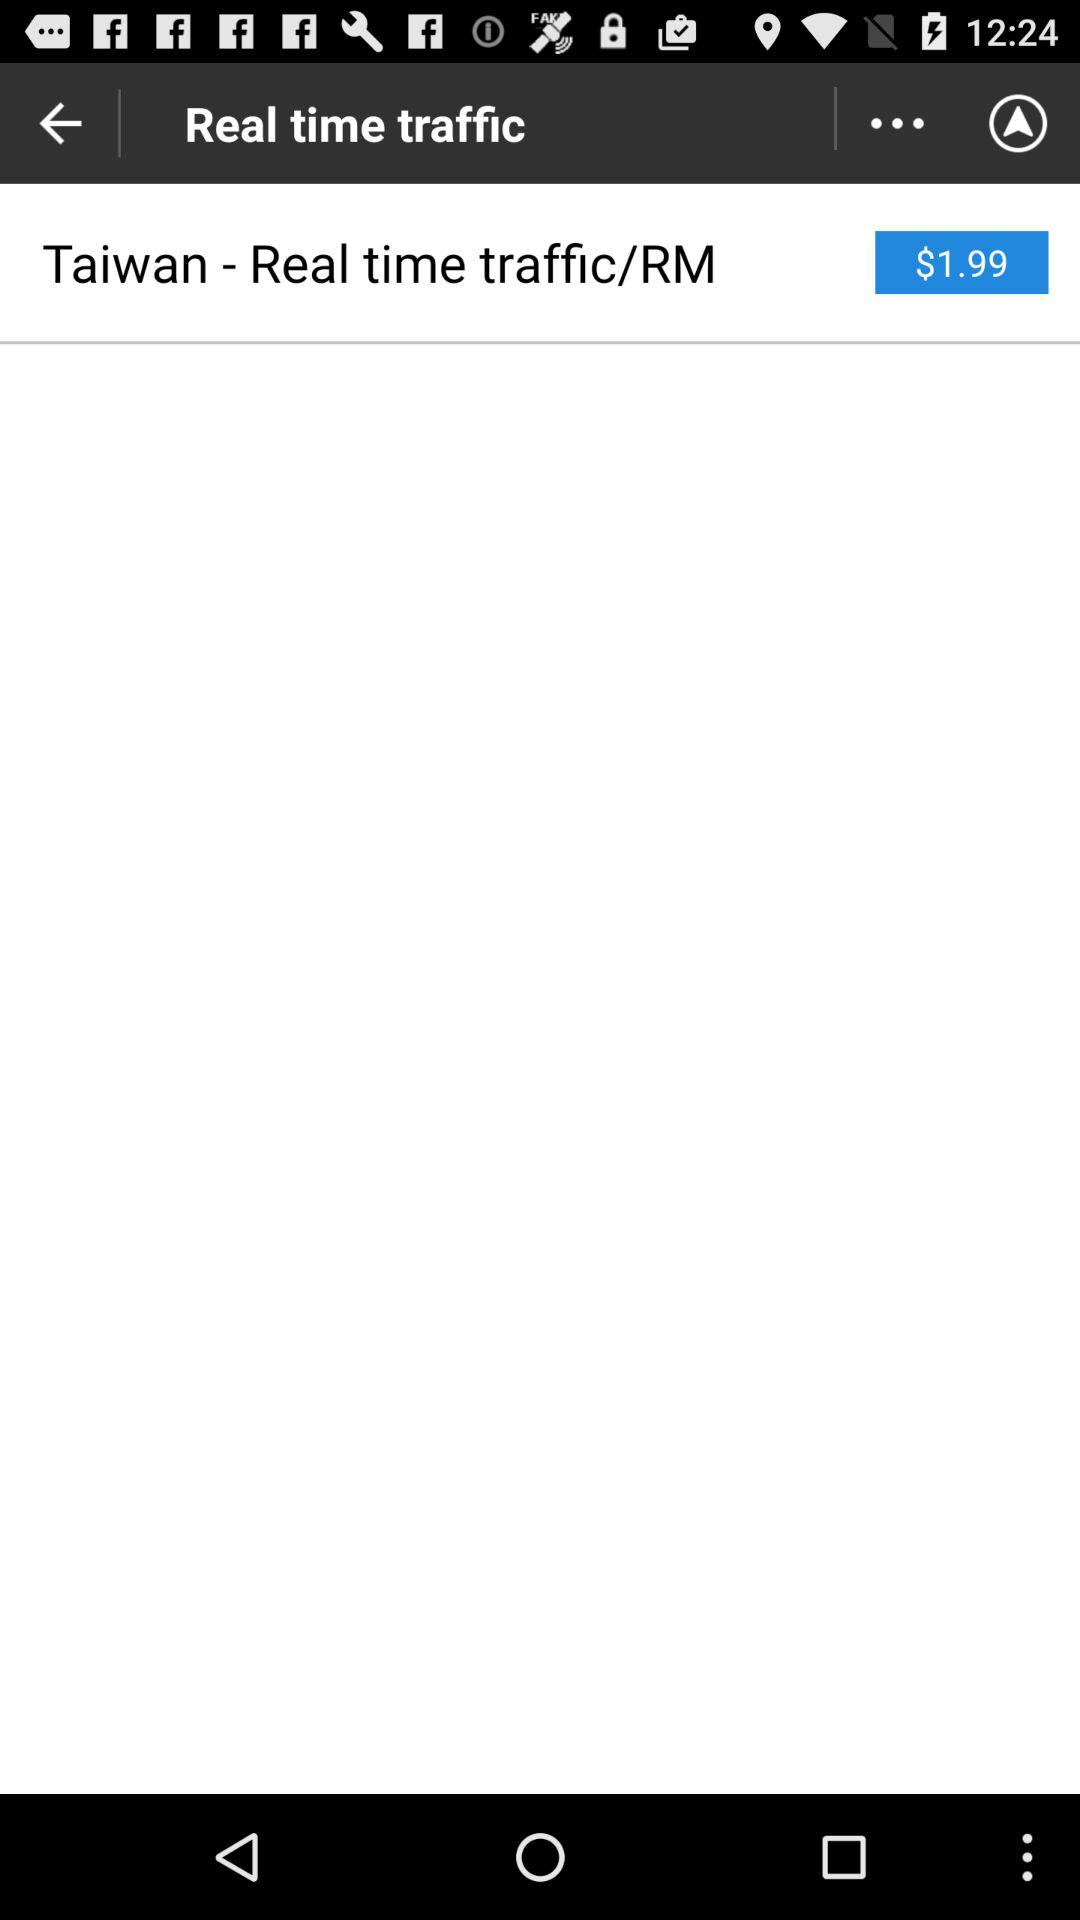How much more does it cost to get real time traffic than to not get it?
Answer the question using a single word or phrase. $1.99 